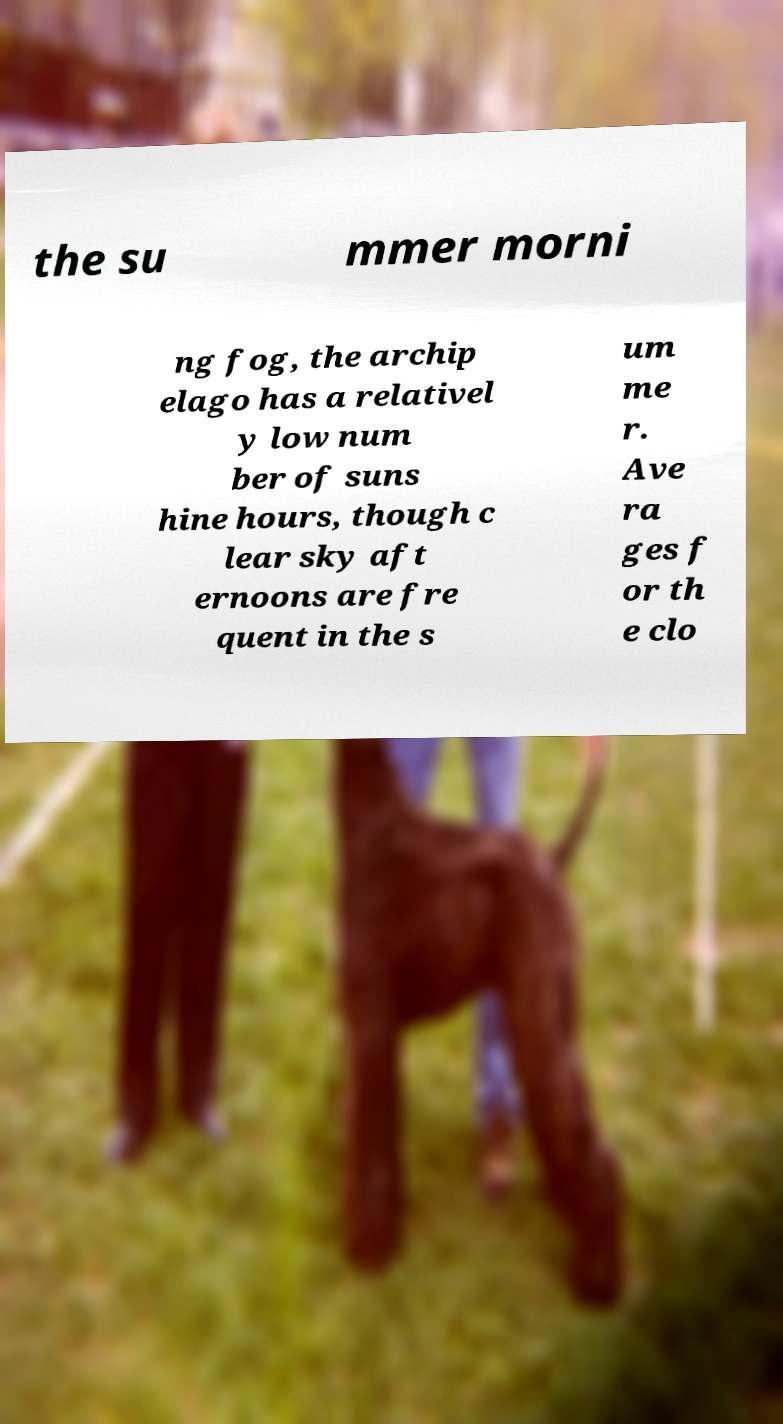There's text embedded in this image that I need extracted. Can you transcribe it verbatim? the su mmer morni ng fog, the archip elago has a relativel y low num ber of suns hine hours, though c lear sky aft ernoons are fre quent in the s um me r. Ave ra ges f or th e clo 